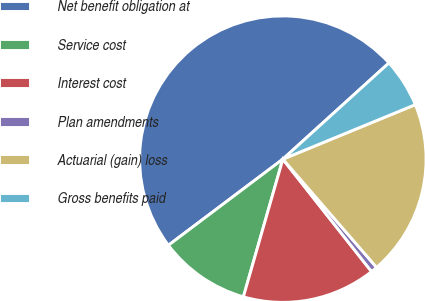Convert chart. <chart><loc_0><loc_0><loc_500><loc_500><pie_chart><fcel>Net benefit obligation at<fcel>Service cost<fcel>Interest cost<fcel>Plan amendments<fcel>Actuarial (gain) loss<fcel>Gross benefits paid<nl><fcel>48.54%<fcel>10.29%<fcel>15.07%<fcel>0.73%<fcel>19.85%<fcel>5.51%<nl></chart> 